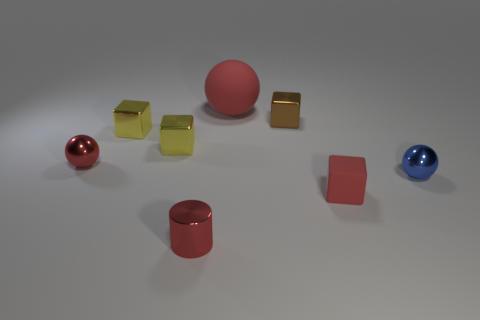How does the lighting in the image affect the appearance of the objects? The overhead lighting creates soft shadows and highlights, enhancing the three-dimensional quality of the objects and giving the metallic ones a glossy shine, while the rubber objects have diffused light reflections.  What might be the purpose of this collection of objects? This assembly might be part of a visual study on materials and colors, possibly for artistic, educational, or design purposes, to illustrate how different textures and colors interact under the same lighting conditions. 